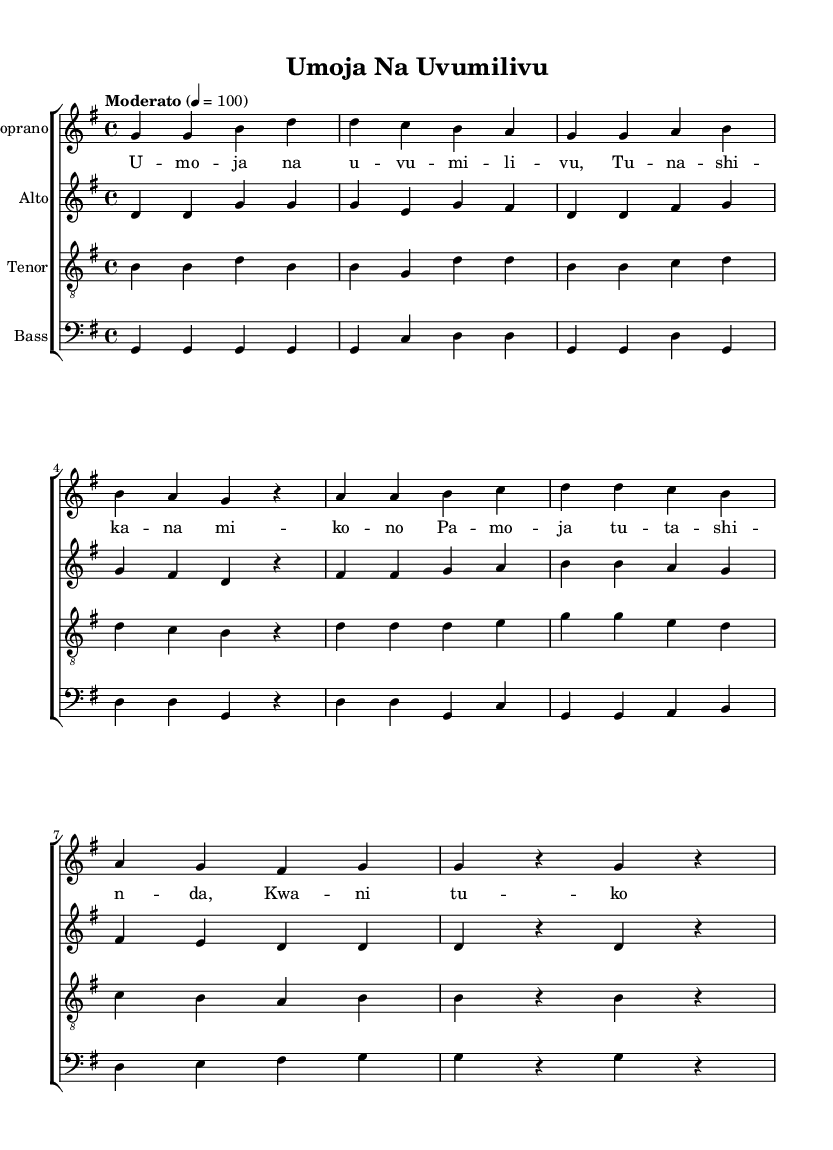What is the key signature of this music? The key signature is G major, which has one sharp (F#). This can be identified at the beginning of the staff where the sharp symbol is placed on the F line of the treble clef.
Answer: G major What is the time signature of this music? The time signature is 4/4, as indicated at the beginning of the score where the two numbers are displayed. This means there are four beats in each measure.
Answer: 4/4 What is the tempo marking for this piece? The tempo marking is "Moderato," and it specifies a tempo of quarter note equals 100 beats per minute. This is indicated at the start of the score below the key and time signature.
Answer: Moderato How many vocal parts are written in this music? There are four vocal parts: Soprano, Alto, Tenor, and Bass. This can be determined by looking at the different staves labeled for each vocal range.
Answer: Four What is the title of this piece? The title of the piece is "Umoja Na Uvumilivu." This is found at the top of the score under the header section.
Answer: Umoja Na Uvumilivu Identify the primary theme of the lyrics. The primary theme of the lyrics revolves around unity and perseverance, emphasizing togetherness. This can be deduced from the wording in the lyrics that repeat the concepts of unity and coming together.
Answer: Unity and perseverance 